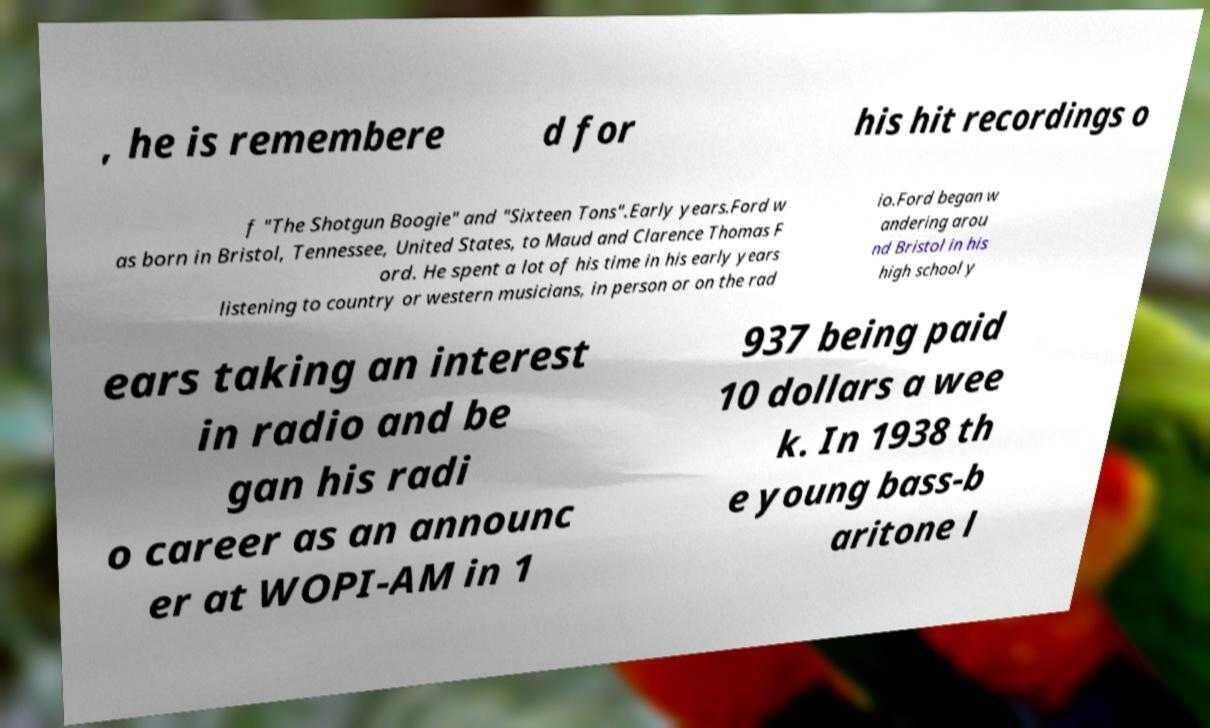What messages or text are displayed in this image? I need them in a readable, typed format. , he is remembere d for his hit recordings o f "The Shotgun Boogie" and "Sixteen Tons".Early years.Ford w as born in Bristol, Tennessee, United States, to Maud and Clarence Thomas F ord. He spent a lot of his time in his early years listening to country or western musicians, in person or on the rad io.Ford began w andering arou nd Bristol in his high school y ears taking an interest in radio and be gan his radi o career as an announc er at WOPI-AM in 1 937 being paid 10 dollars a wee k. In 1938 th e young bass-b aritone l 